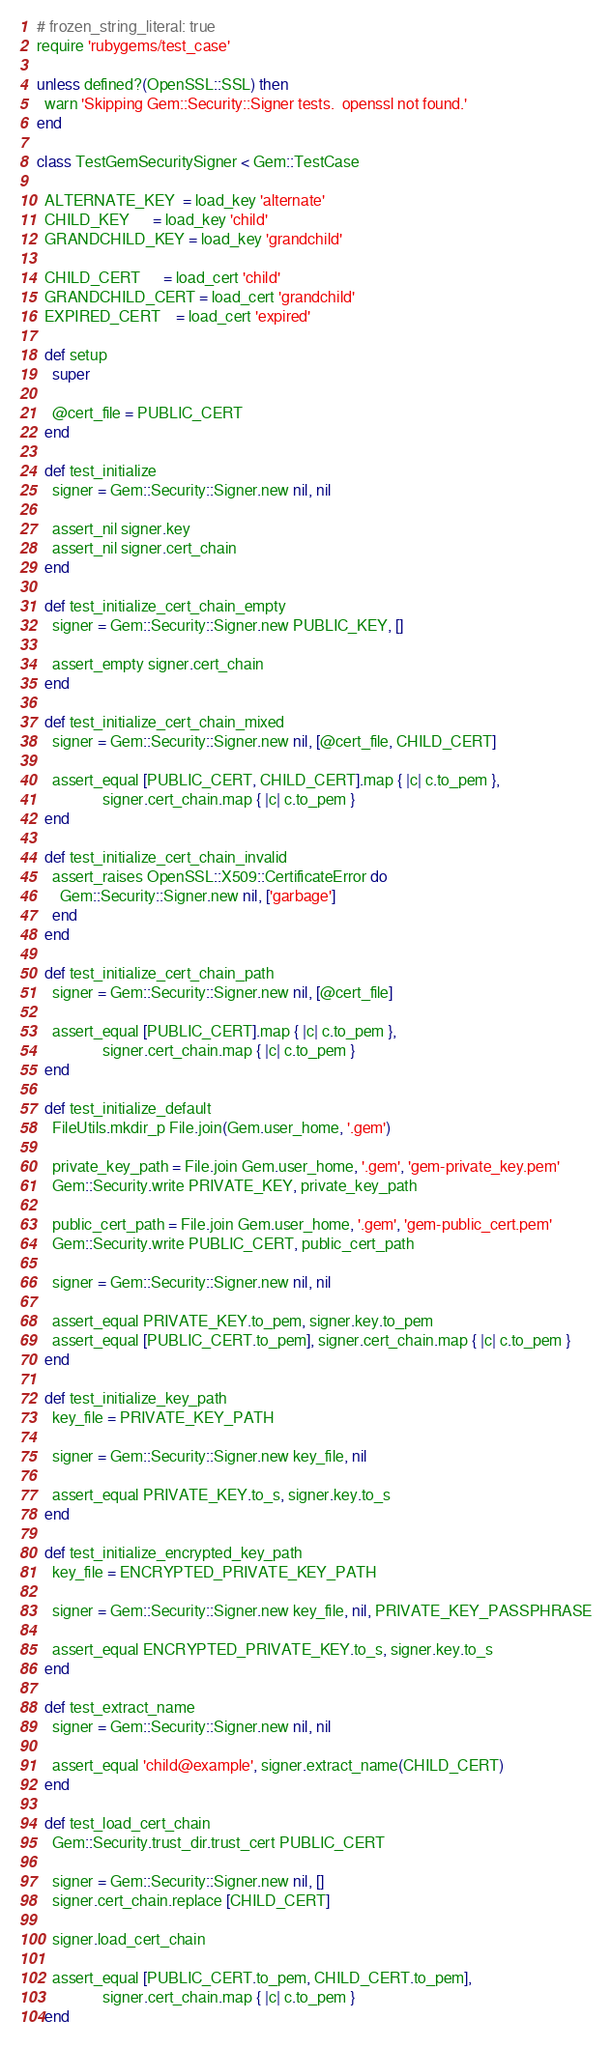Convert code to text. <code><loc_0><loc_0><loc_500><loc_500><_Ruby_># frozen_string_literal: true
require 'rubygems/test_case'

unless defined?(OpenSSL::SSL) then
  warn 'Skipping Gem::Security::Signer tests.  openssl not found.'
end

class TestGemSecuritySigner < Gem::TestCase

  ALTERNATE_KEY  = load_key 'alternate'
  CHILD_KEY      = load_key 'child'
  GRANDCHILD_KEY = load_key 'grandchild'

  CHILD_CERT      = load_cert 'child'
  GRANDCHILD_CERT = load_cert 'grandchild'
  EXPIRED_CERT    = load_cert 'expired'

  def setup
    super

    @cert_file = PUBLIC_CERT
  end

  def test_initialize
    signer = Gem::Security::Signer.new nil, nil

    assert_nil signer.key
    assert_nil signer.cert_chain
  end

  def test_initialize_cert_chain_empty
    signer = Gem::Security::Signer.new PUBLIC_KEY, []

    assert_empty signer.cert_chain
  end

  def test_initialize_cert_chain_mixed
    signer = Gem::Security::Signer.new nil, [@cert_file, CHILD_CERT]

    assert_equal [PUBLIC_CERT, CHILD_CERT].map { |c| c.to_pem },
                 signer.cert_chain.map { |c| c.to_pem }
  end

  def test_initialize_cert_chain_invalid
    assert_raises OpenSSL::X509::CertificateError do
      Gem::Security::Signer.new nil, ['garbage']
    end
  end

  def test_initialize_cert_chain_path
    signer = Gem::Security::Signer.new nil, [@cert_file]

    assert_equal [PUBLIC_CERT].map { |c| c.to_pem },
                 signer.cert_chain.map { |c| c.to_pem }
  end

  def test_initialize_default
    FileUtils.mkdir_p File.join(Gem.user_home, '.gem')

    private_key_path = File.join Gem.user_home, '.gem', 'gem-private_key.pem'
    Gem::Security.write PRIVATE_KEY, private_key_path

    public_cert_path = File.join Gem.user_home, '.gem', 'gem-public_cert.pem'
    Gem::Security.write PUBLIC_CERT, public_cert_path

    signer = Gem::Security::Signer.new nil, nil

    assert_equal PRIVATE_KEY.to_pem, signer.key.to_pem
    assert_equal [PUBLIC_CERT.to_pem], signer.cert_chain.map { |c| c.to_pem }
  end

  def test_initialize_key_path
    key_file = PRIVATE_KEY_PATH

    signer = Gem::Security::Signer.new key_file, nil

    assert_equal PRIVATE_KEY.to_s, signer.key.to_s
  end

  def test_initialize_encrypted_key_path
    key_file = ENCRYPTED_PRIVATE_KEY_PATH

    signer = Gem::Security::Signer.new key_file, nil, PRIVATE_KEY_PASSPHRASE

    assert_equal ENCRYPTED_PRIVATE_KEY.to_s, signer.key.to_s
  end

  def test_extract_name
    signer = Gem::Security::Signer.new nil, nil

    assert_equal 'child@example', signer.extract_name(CHILD_CERT)
  end

  def test_load_cert_chain
    Gem::Security.trust_dir.trust_cert PUBLIC_CERT

    signer = Gem::Security::Signer.new nil, []
    signer.cert_chain.replace [CHILD_CERT]

    signer.load_cert_chain

    assert_equal [PUBLIC_CERT.to_pem, CHILD_CERT.to_pem],
                 signer.cert_chain.map { |c| c.to_pem }
  end
</code> 